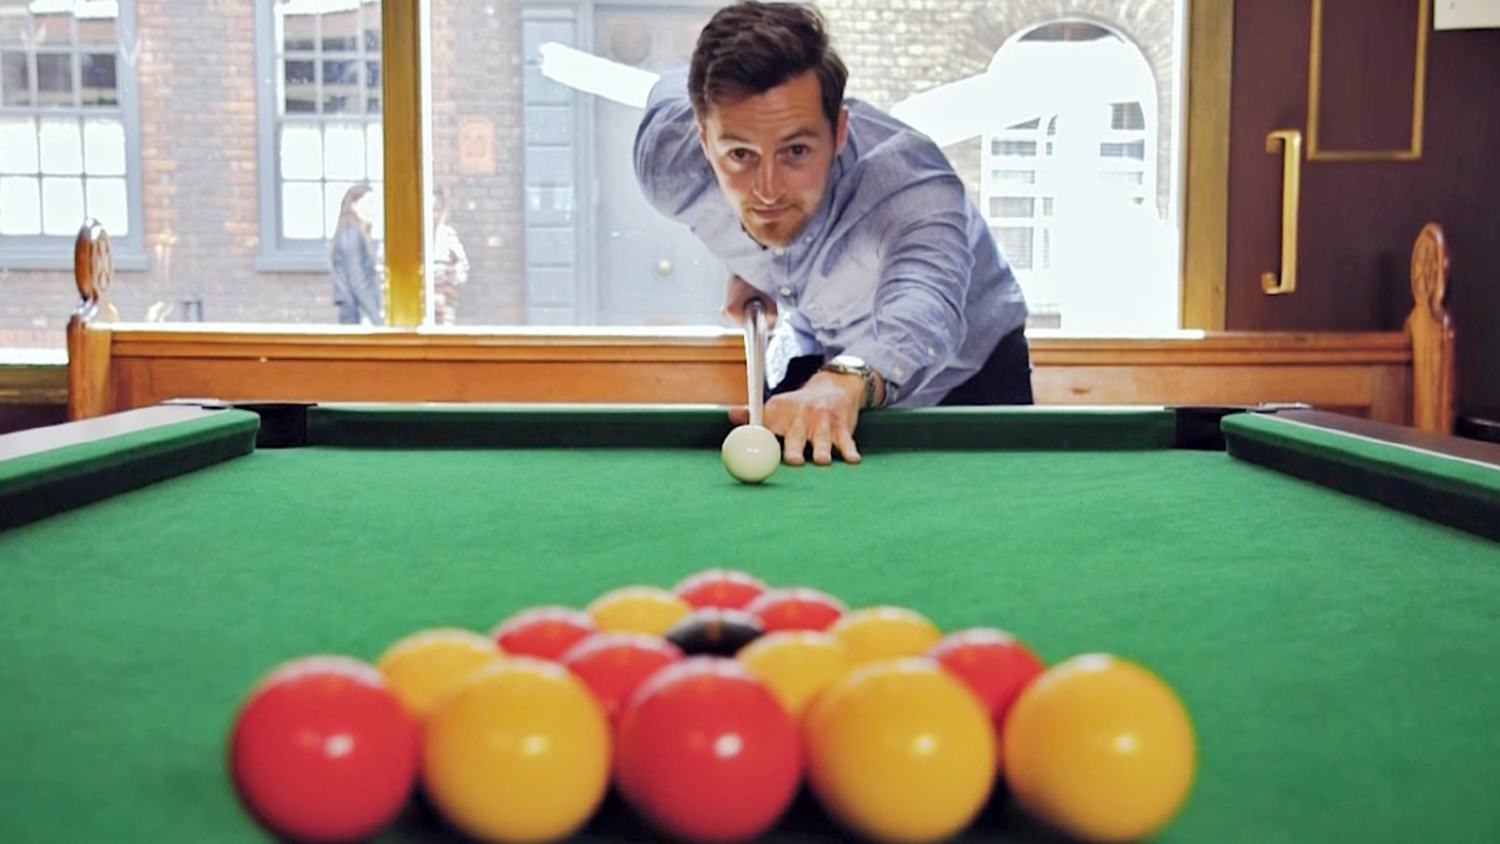Imagine the scene if the pool hall was located in the middle of a science fiction city. What changes would you expect to see? If this pool hall were located in the middle of a science fiction city, the scene would likely be drastically different. The pool table might be equipped with advanced technology, such as a holographic interface for scoring and monitoring precision. The balls themselves might glow with neon light or change patterns as they move. The lighting in the hall would probably have a futuristic touch, with LED panels providing adjustable, ambient glow. Outside the window, you might see flying vehicles instead of traditional ones, towering skyscrapers, and perhaps even otherworldly flora and fauna. The entire atmosphere would have a high-tech, otherworldly feel, seamlessly blending the thrill of pool with futuristic elements. Describe a specific scenario that could happen in this science fiction pool hall. In this science fiction pool hall, a tournament could be underway with players competing not just in skill but also in strategy enhanced by technology. Imagine a scenario where one of the players, let's call her Aria, uses a wrist device to simulate potential shots, projecting holographic paths onto the table for visualization. As Aria lines up her shot, a robotic assistant adjusts the environmental conditions for optimal gameplay, like modifying the table's friction or the ball's weight. Spectators in the hall enjoy real-time data on a floating screen that analyzes each stroke's velocity, angle, and spin, providing insights into the player's choices. All this happening against the backdrop of a bustling, neon-lit cityscape visible through the huge panoramic windows. This blend of traditional skill and advanced technology would make the game both familiar and thrillingly novel. 